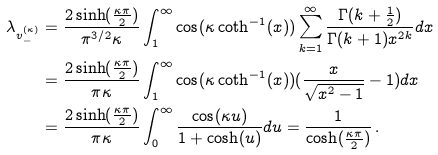Convert formula to latex. <formula><loc_0><loc_0><loc_500><loc_500>\lambda _ { v _ { - } ^ { ( \kappa ) } } & = \frac { 2 \sinh ( \frac { \kappa \pi } { 2 } ) } { \pi ^ { 3 / 2 } \kappa } \int _ { 1 } ^ { \infty } \cos ( \kappa \coth ^ { - 1 } ( x ) ) \sum _ { k = 1 } ^ { \infty } \frac { \Gamma ( k + \frac { 1 } { 2 } ) } { \Gamma ( k + 1 ) x ^ { 2 k } } d x \\ & = \frac { 2 \sinh ( \frac { \kappa \pi } { 2 } ) } { \pi \kappa } \int _ { 1 } ^ { \infty } \cos ( \kappa \coth ^ { - 1 } ( x ) ) ( \frac { x } { \sqrt { x ^ { 2 } - 1 } } - 1 ) d x \\ & = \frac { 2 \sinh ( \frac { \kappa \pi } { 2 } ) } { \pi \kappa } \int _ { 0 } ^ { \infty } \frac { \cos ( \kappa u ) } { 1 + \cosh ( u ) } d u = \frac { 1 } { \cosh ( \frac { \kappa \pi } { 2 } ) } \, .</formula> 